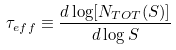<formula> <loc_0><loc_0><loc_500><loc_500>\tau _ { e f f } \equiv \frac { d \log [ N _ { T O T } ( S ) ] } { d \log S }</formula> 